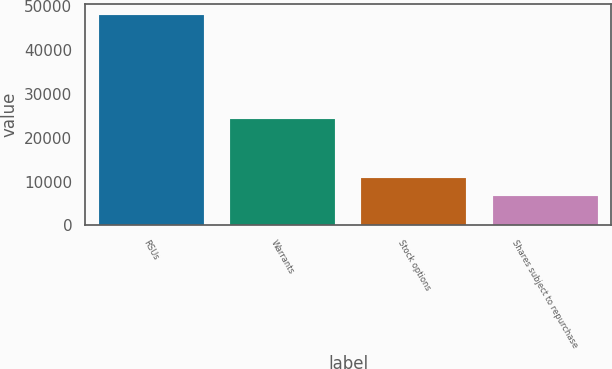Convert chart. <chart><loc_0><loc_0><loc_500><loc_500><bar_chart><fcel>RSUs<fcel>Warrants<fcel>Stock options<fcel>Shares subject to repurchase<nl><fcel>48069<fcel>24329<fcel>10780.2<fcel>6637<nl></chart> 